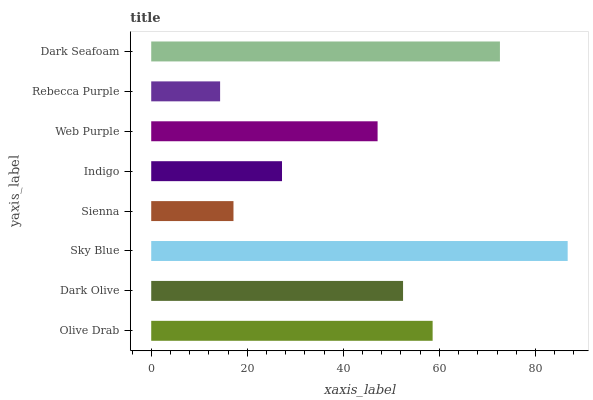Is Rebecca Purple the minimum?
Answer yes or no. Yes. Is Sky Blue the maximum?
Answer yes or no. Yes. Is Dark Olive the minimum?
Answer yes or no. No. Is Dark Olive the maximum?
Answer yes or no. No. Is Olive Drab greater than Dark Olive?
Answer yes or no. Yes. Is Dark Olive less than Olive Drab?
Answer yes or no. Yes. Is Dark Olive greater than Olive Drab?
Answer yes or no. No. Is Olive Drab less than Dark Olive?
Answer yes or no. No. Is Dark Olive the high median?
Answer yes or no. Yes. Is Web Purple the low median?
Answer yes or no. Yes. Is Rebecca Purple the high median?
Answer yes or no. No. Is Sky Blue the low median?
Answer yes or no. No. 